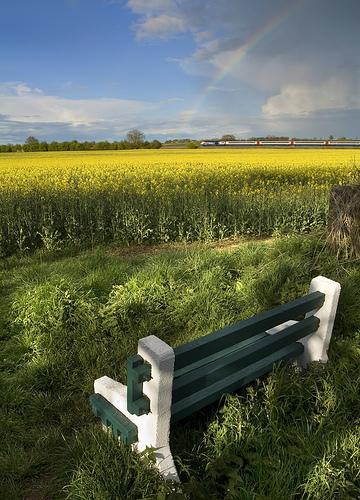For the product advertisement task: Highlight the role of the bench in the advertisement's setting. The green bench serves as a focal point, offering a comfortable and idyllic spot to relax and enjoy the natural beauty of the surrounding environment. Summarize the visual content of the image in a single sentence. The image depicts a peaceful scene with a green bench surrounded by yellow flowers, a train passing by, and a rainbow in a clear blue sky. For the multi-choice VQA task: What is the primary subject of the image?  b) Bench What are the main elements of the scenery in the image? A green bench, yellow flowers in a field, a train in the distance, and a rainbow in a clear blue sky with white clouds. Mention any objects near the bench and their colors. There are yellow flowers in the field near the bench and white legs on the bench. What is the atmosphere of the scene presented in the image? The atmosphere of the scene is serene and tranquil, with a beautiful view of grass, flowers, and a rainbow in a clear blue sky. 